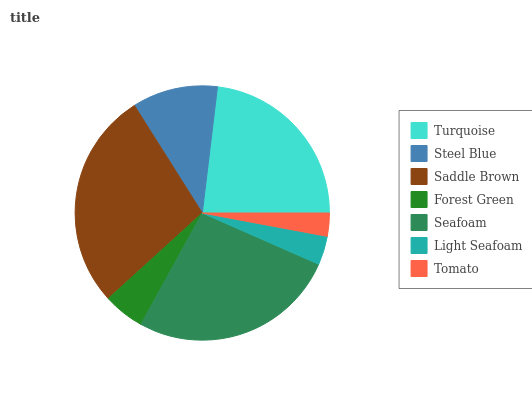Is Tomato the minimum?
Answer yes or no. Yes. Is Saddle Brown the maximum?
Answer yes or no. Yes. Is Steel Blue the minimum?
Answer yes or no. No. Is Steel Blue the maximum?
Answer yes or no. No. Is Turquoise greater than Steel Blue?
Answer yes or no. Yes. Is Steel Blue less than Turquoise?
Answer yes or no. Yes. Is Steel Blue greater than Turquoise?
Answer yes or no. No. Is Turquoise less than Steel Blue?
Answer yes or no. No. Is Steel Blue the high median?
Answer yes or no. Yes. Is Steel Blue the low median?
Answer yes or no. Yes. Is Turquoise the high median?
Answer yes or no. No. Is Seafoam the low median?
Answer yes or no. No. 